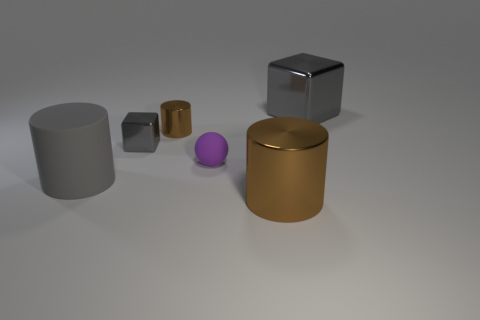The shiny thing behind the brown thing that is to the left of the large cylinder that is to the right of the gray matte thing is what color?
Offer a very short reply. Gray. Is the number of small brown shiny objects to the left of the small matte thing the same as the number of brown cylinders?
Your answer should be very brief. No. Is there anything else that has the same material as the large gray block?
Your response must be concise. Yes. Does the large metal cylinder have the same color as the large metal object that is behind the big brown thing?
Give a very brief answer. No. There is a large cylinder to the right of the large rubber cylinder that is on the left side of the big block; are there any matte objects that are on the right side of it?
Your answer should be compact. No. Are there fewer purple matte things behind the tiny brown metallic object than tiny brown rubber things?
Give a very brief answer. No. What number of other objects are the same shape as the tiny brown object?
Provide a short and direct response. 2. How many things are matte things that are left of the small purple rubber ball or large gray objects behind the gray matte cylinder?
Provide a succinct answer. 2. There is a gray thing that is right of the large matte thing and on the left side of the tiny brown shiny cylinder; how big is it?
Provide a short and direct response. Small. There is a brown object that is in front of the purple rubber ball; does it have the same shape as the tiny matte object?
Your answer should be compact. No. 